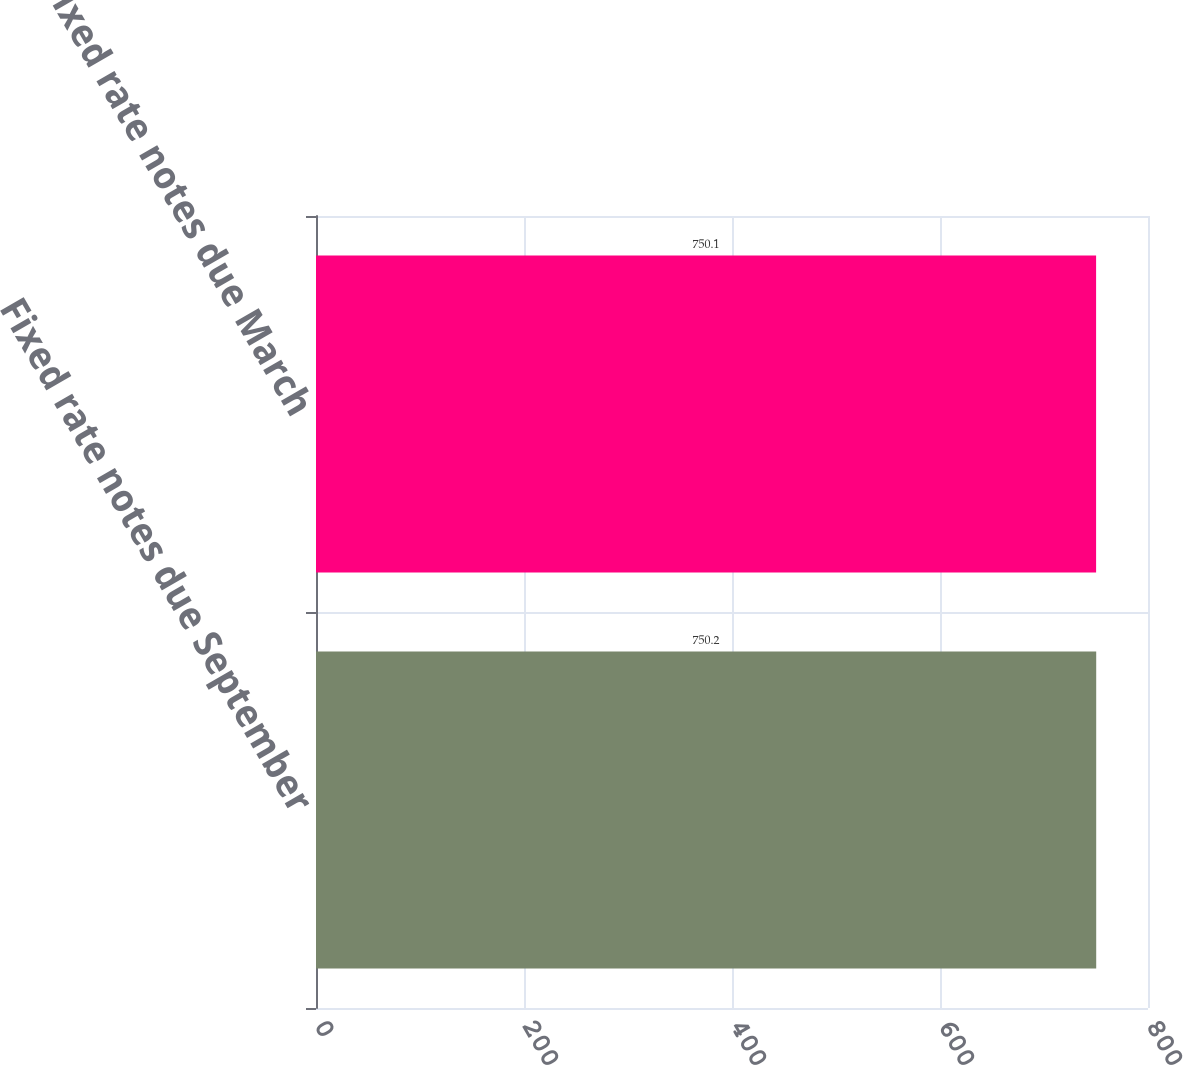<chart> <loc_0><loc_0><loc_500><loc_500><bar_chart><fcel>Fixed rate notes due September<fcel>Fixed rate notes due March<nl><fcel>750.2<fcel>750.1<nl></chart> 